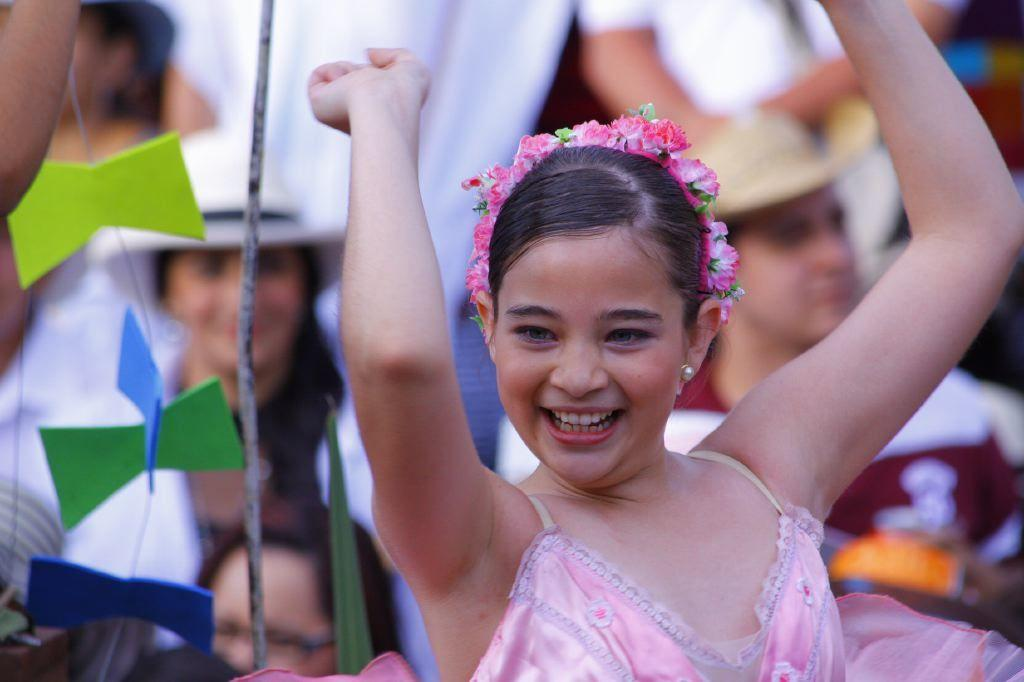Who or what can be seen in the image? There are people in the image. Can you describe the objects on the left side of the image? Unfortunately, the provided facts do not specify the objects on the left side of the image. However, we can still discuss the people present in the image. How many times has the oven been folded in the image? There is no oven present in the image, so it cannot be folded or have any folding-related actions. 